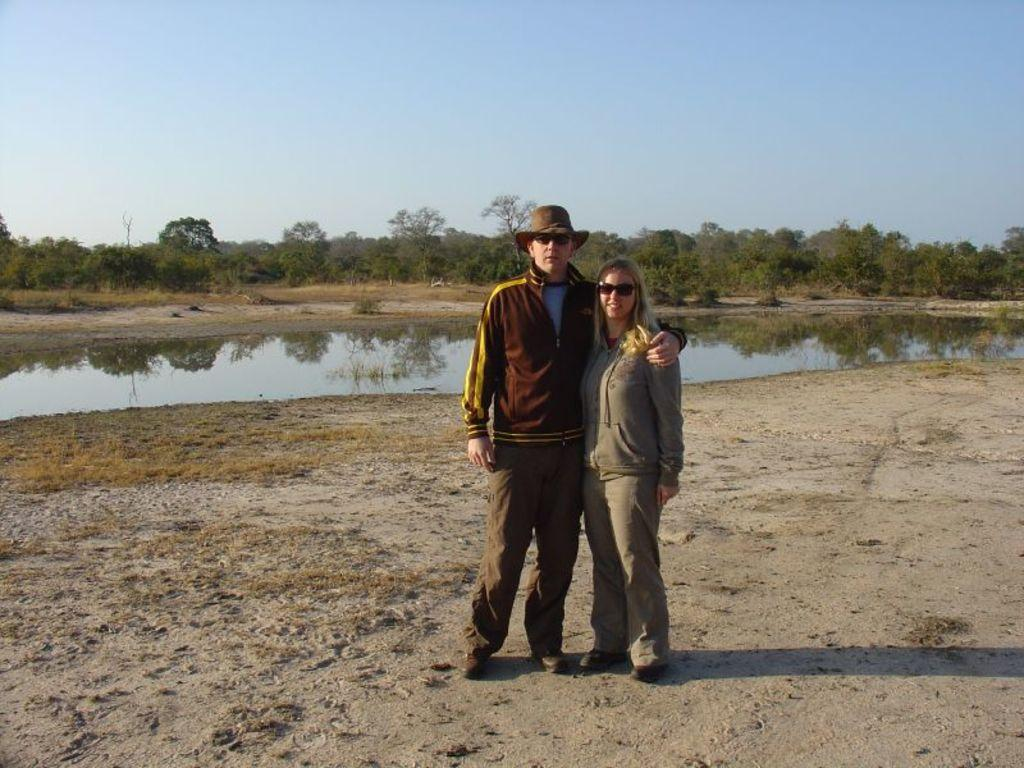Who are the people in the image? There is a man and a woman standing in the image. What are the man and woman wearing? The man is wearing goggles and a hat, while the woman is wearing goggles. What can be seen in the background of the image? There is water, trees, and the sky visible in the background of the image. What type of seed is the monkey holding in the image? There is no monkey present in the image, so it is not possible to determine what type of seed the monkey might be holding. 